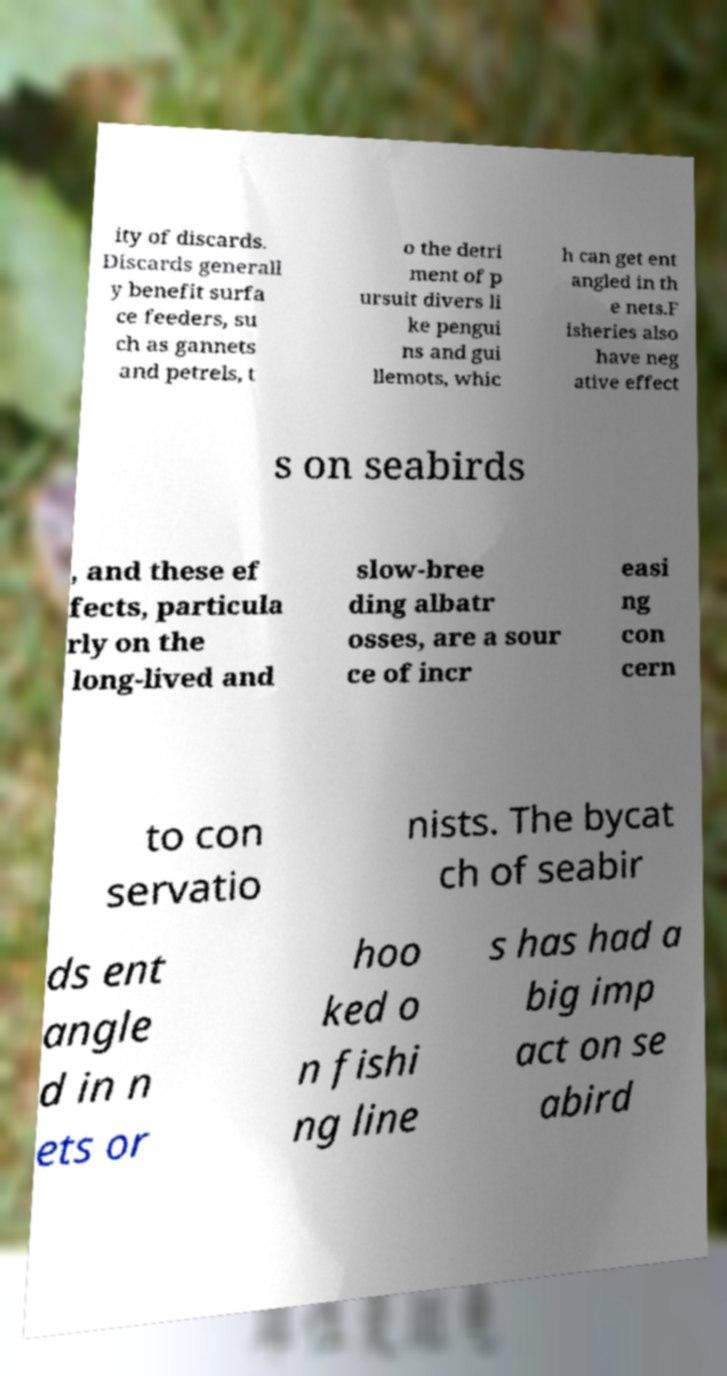I need the written content from this picture converted into text. Can you do that? ity of discards. Discards generall y benefit surfa ce feeders, su ch as gannets and petrels, t o the detri ment of p ursuit divers li ke pengui ns and gui llemots, whic h can get ent angled in th e nets.F isheries also have neg ative effect s on seabirds , and these ef fects, particula rly on the long-lived and slow-bree ding albatr osses, are a sour ce of incr easi ng con cern to con servatio nists. The bycat ch of seabir ds ent angle d in n ets or hoo ked o n fishi ng line s has had a big imp act on se abird 